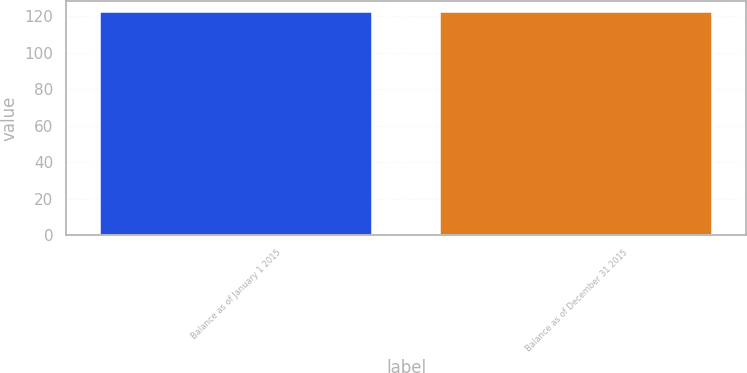Convert chart to OTSL. <chart><loc_0><loc_0><loc_500><loc_500><bar_chart><fcel>Balance as of January 1 2015<fcel>Balance as of December 31 2015<nl><fcel>122<fcel>122.1<nl></chart> 